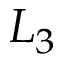<formula> <loc_0><loc_0><loc_500><loc_500>L _ { 3 }</formula> 